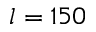<formula> <loc_0><loc_0><loc_500><loc_500>l = 1 5 0</formula> 